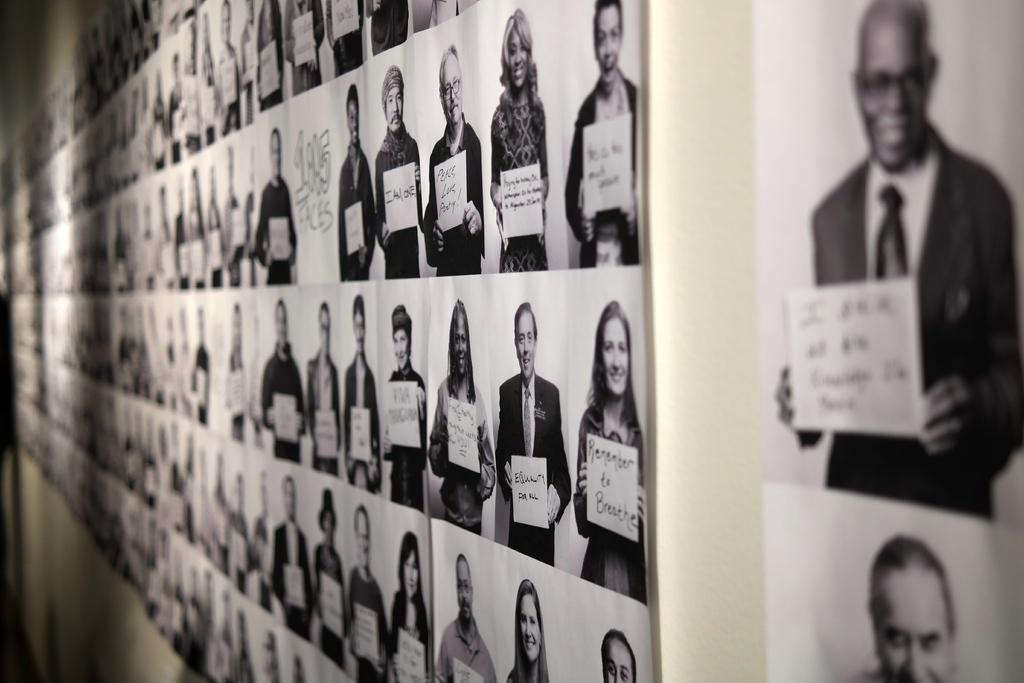What can be seen on the wall in the image? There are photos of people on the wall. What are the people in the photos doing? The people in the photos are holding boards. What can be seen on the boards? Words are written on the boards. How many beds can be seen in the image? There are no beds present in the image. What type of jam is being spread on the boards in the image? There is no jam present in the image; the boards have words written on them. 